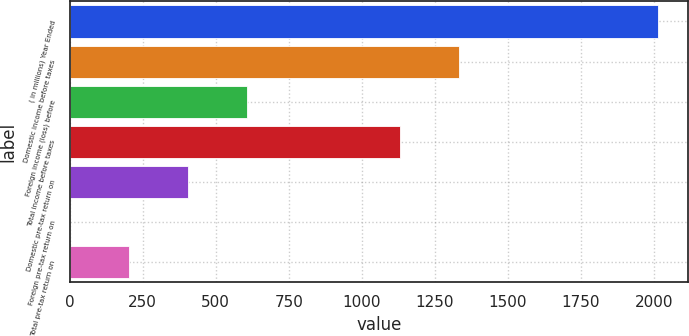<chart> <loc_0><loc_0><loc_500><loc_500><bar_chart><fcel>( in millions) Year Ended<fcel>Domestic income before taxes<fcel>Foreign income (loss) before<fcel>Total income before taxes<fcel>Domestic pre-tax return on<fcel>Foreign pre-tax return on<fcel>Total pre-tax return on<nl><fcel>2016<fcel>1331.92<fcel>605.36<fcel>1130.4<fcel>403.84<fcel>0.8<fcel>202.32<nl></chart> 